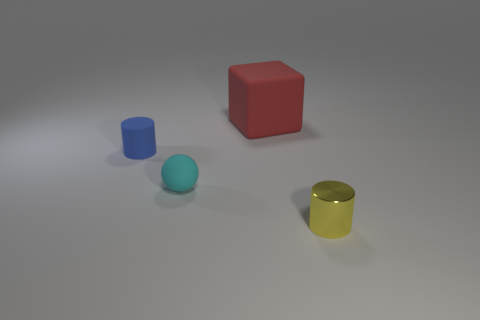Add 3 yellow metallic things. How many objects exist? 7 Subtract all blocks. How many objects are left? 3 Subtract 0 brown spheres. How many objects are left? 4 Subtract all tiny purple blocks. Subtract all blue matte cylinders. How many objects are left? 3 Add 4 cyan rubber balls. How many cyan rubber balls are left? 5 Add 2 small matte objects. How many small matte objects exist? 4 